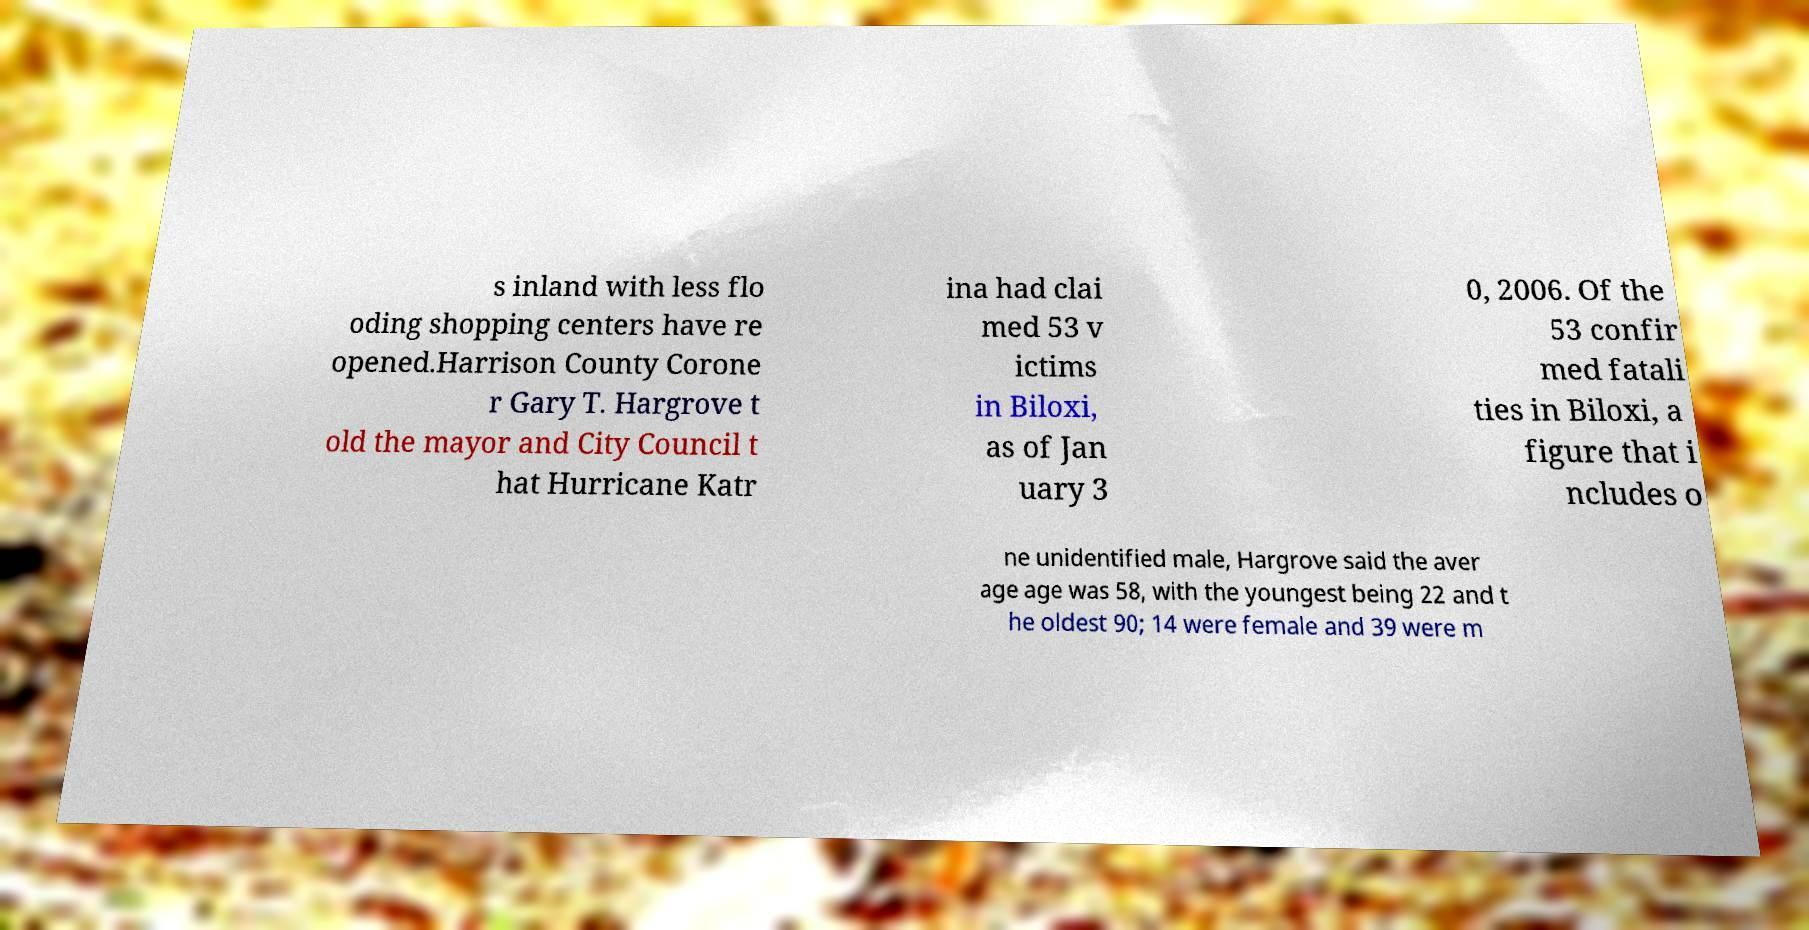Please identify and transcribe the text found in this image. s inland with less flo oding shopping centers have re opened.Harrison County Corone r Gary T. Hargrove t old the mayor and City Council t hat Hurricane Katr ina had clai med 53 v ictims in Biloxi, as of Jan uary 3 0, 2006. Of the 53 confir med fatali ties in Biloxi, a figure that i ncludes o ne unidentified male, Hargrove said the aver age age was 58, with the youngest being 22 and t he oldest 90; 14 were female and 39 were m 